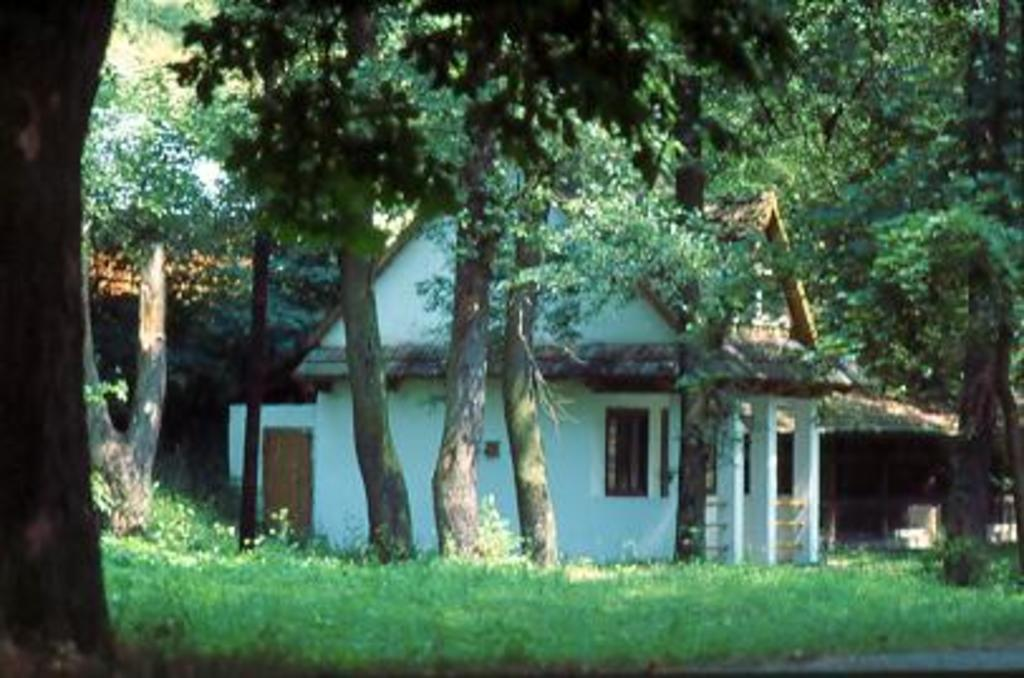What type of structure is visible in the image? There is a house in the image. What features can be seen on the house? The house has windows and pillars. What type of vegetation is present in the image? There are trees with branches and leaves in the image. What is the color of the grass in the image? The grass in the image is green in color. Can you tell me how many kettles are visible in the image? There are no kettles present in the image. What type of flock is flying over the house in the image? There are no birds or flocks visible in the image. 